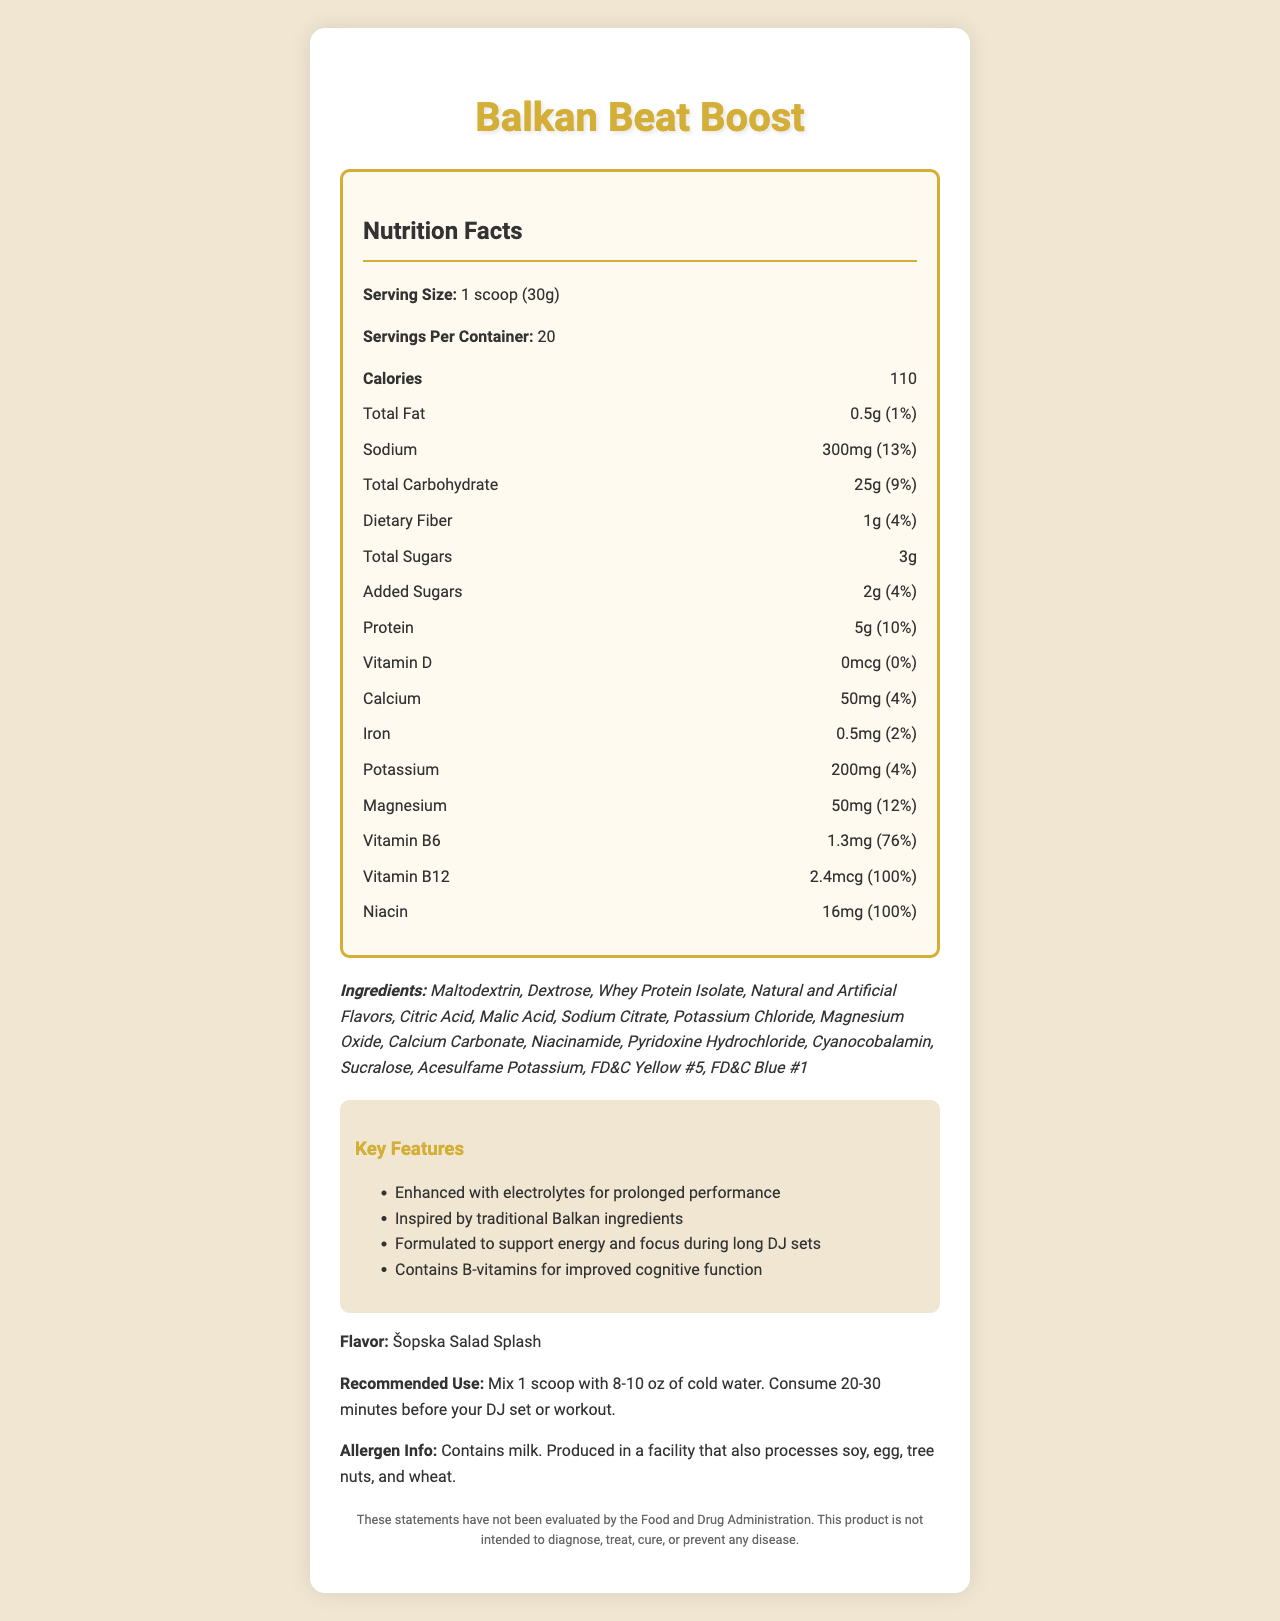what is the product name? The product name is stated at the top of the document as "Balkan Beat Boost."
Answer: Balkan Beat Boost how many servings are in one container? The document lists "Servings Per Container" as 20.
Answer: 20 what is the serving size? The serving size is specified as "1 scoop (30g)."
Answer: 1 scoop (30g) how much sodium is in one serving? The document states that there are 300mg of sodium per serving.
Answer: 300mg list all the ingredients The ingredients are listed under the "Ingredients" section of the document.
Answer: Maltodextrin, Dextrose, Whey Protein Isolate, Natural and Artificial Flavors, Citric Acid, Malic Acid, Sodium Citrate, Potassium Chloride, Magnesium Oxide, Calcium Carbonate, Niacinamide, Pyridoxine Hydrochloride, Cyanocobalamin, Sucralose, Acesulfame Potassium, FD&C Yellow #5, FD&C Blue #1 how many calories does one serving contain? The document states that there are 110 calories per serving.
Answer: 110 how much total carbohydrate does one serving contain? The document states that there are 25g of total carbohydrates per serving.
Answer: 25g how much protein does one serving contain? The document states that there are 5g of protein per serving.
Answer: 5g which vitamin B levels are displayed, and what are their daily values? A. Vitamin B6 76%, Vitamin B12 100% B. Vitamin B6 76%, Vitamin B12 95% C. Vitamin B1 76%, Vitamin B12 100% D. Niacin 50%, Vitamin B2 50% The document shows that Vitamin B6 has a daily value of 76% and Vitamin B12 has a daily value of 100%.
Answer: A what are the key features emphasized in the product? A. Enhanced energy, Balkan-inspired ingredients B. Weight loss support C. Muscle building D. Cardiovascular health The document states that the key features include "Enhanced with electrolytes for prolonged performance," "Inspired by traditional Balkan ingredients," as well as support for energy and cognitive function during long DJ sets.
Answer: A is the product allergen-free? The document states in the allergen info: "Contains milk. Produced in a facility that also processes soy, egg, tree nuts, and wheat."
Answer: No summarize the main idea of the document The document gives a comprehensive overview of the supplement, showcasing its nutritional aspects, key features, ingredients, and usage instructions, with additional information on allergens and compliance.
Answer: The document is a nutrition facts label for a Balkan-inspired pre-workout supplement called Balkan Beat Boost. It highlights nutritional content such as calories, carbohydrates, proteins, fats, and micronutrients like vitamins and minerals. The product features key ingredients inspired by traditional Balkan foods and is designed to enhance performance during long activities, with special emphasis on electrolyte content. Additionally, there are details on recommended usage, allergen information, and a disclaimer. what is the daily value percentage of magnesium? The document lists the daily value of magnesium as 12%.
Answer: 12% are any Balkan ingredients used in the product? The product includes Balkan-inspired ingredients such as Ajvar extract, dried kajmak powder, and Rakija essence. This information is provided in the section titled "Balkan-inspired ingredients."
Answer: Yes what colors are used to enhance the appearance of the product? The ingredients list shows that FD&C Yellow #5 and FD&C Blue #1 are used for coloring.
Answer: FD&C Yellow #5, FD&C Blue #1 does the document mention if the product is intended to diagnose, treat, cure, or prevent any disease? The disclaimer at the end of the document specifically states, "These statements have not been evaluated by the Food and Drug Administration. This product is not intended to diagnose, treat, cure, or prevent any disease."
Answer: No what is the recommended use for the product? The recommended use is described in the document under the section "Recommended Use."
Answer: Mix 1 scoop with 8-10 oz of cold water. Consume 20-30 minutes before your DJ set or workout. how many grams of added sugars are there in one serving? The document states that there are 2g of added sugars per serving.
Answer: 2g does the product contain any vitamin D? The document lists vitamin D as 0mcg with a daily value of 0%.
Answer: No 